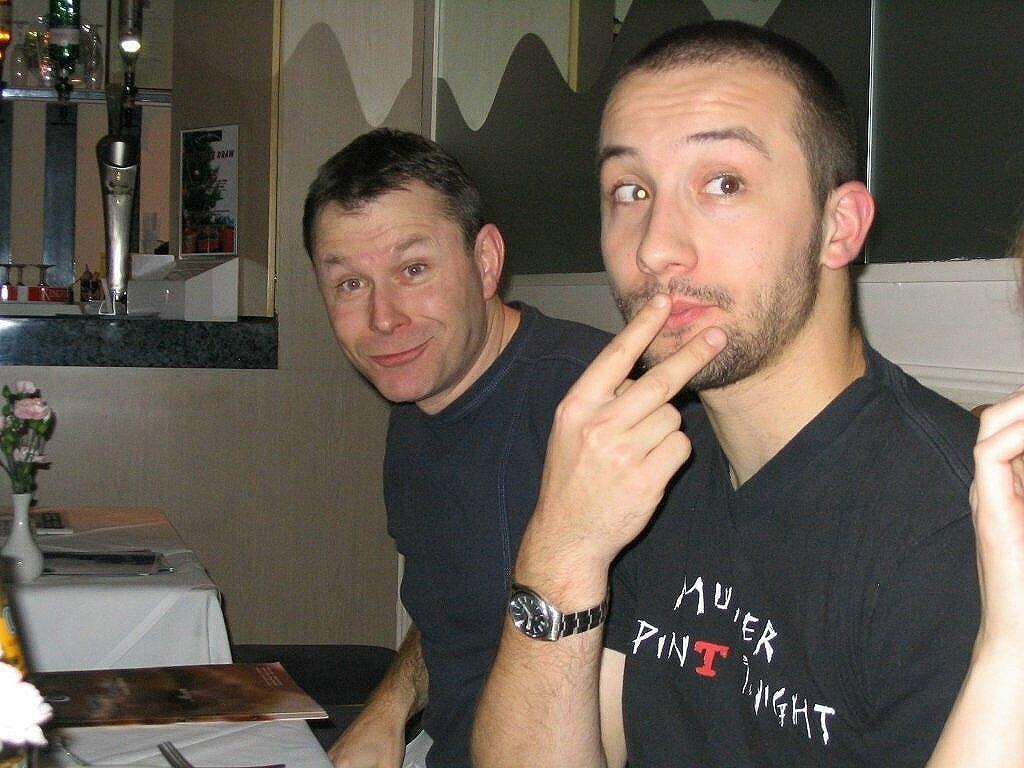Can you describe this image briefly? In this image in the foreground there are two persons sitting, and on the right side there is one person's hand is visible. And on the left side there are some tables, on the tables there are some flowers, cards, spoons, cloth. And in the background there is a wall, bottles and some other objects and poster on the wall. 